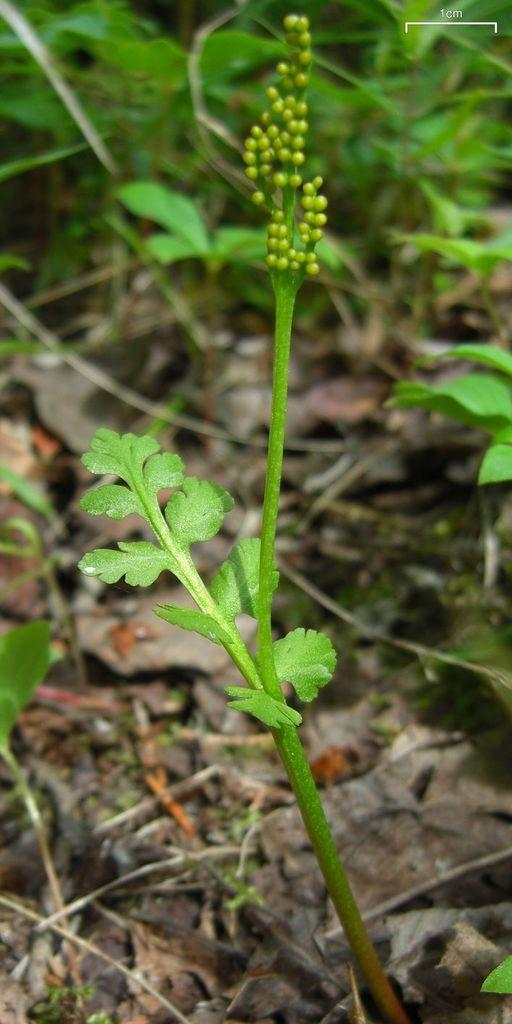What type of living organisms can be seen in the image? Plants can be seen in the image. Can you describe a specific plant in the image? There is a plant with buds in the image. What type of mist can be seen surrounding the plants in the image? There is no mist present in the image; it only features plants. 